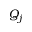Convert formula to latex. <formula><loc_0><loc_0><loc_500><loc_500>Q _ { j }</formula> 